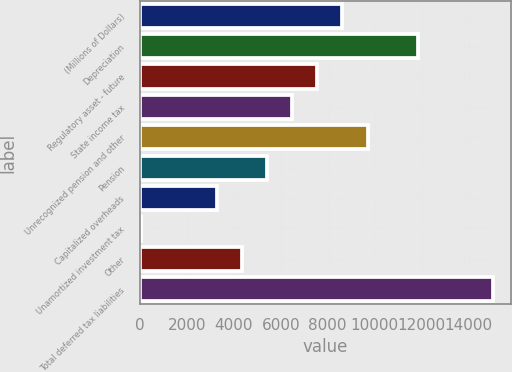Convert chart to OTSL. <chart><loc_0><loc_0><loc_500><loc_500><bar_chart><fcel>(Millions of Dollars)<fcel>Depreciation<fcel>Regulatory asset - future<fcel>State income tax<fcel>Unrecognized pension and other<fcel>Pension<fcel>Capitalized overheads<fcel>Unamortized investment tax<fcel>Other<fcel>Total deferred tax liabilities<nl><fcel>8626.2<fcel>11843.4<fcel>7553.8<fcel>6481.4<fcel>9698.6<fcel>5409<fcel>3264.2<fcel>47<fcel>4336.6<fcel>15060.6<nl></chart> 